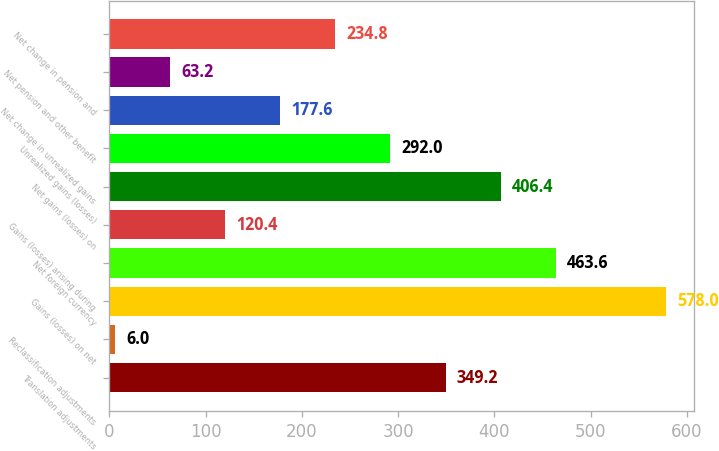Convert chart. <chart><loc_0><loc_0><loc_500><loc_500><bar_chart><fcel>Translation adjustments<fcel>Reclassification adjustments<fcel>Gains (losses) on net<fcel>Net foreign currency<fcel>Gains (losses) arising during<fcel>Net gains (losses) on<fcel>Unrealized gains (losses)<fcel>Net change in unrealized gains<fcel>Net pension and other benefit<fcel>Net change in pension and<nl><fcel>349.2<fcel>6<fcel>578<fcel>463.6<fcel>120.4<fcel>406.4<fcel>292<fcel>177.6<fcel>63.2<fcel>234.8<nl></chart> 